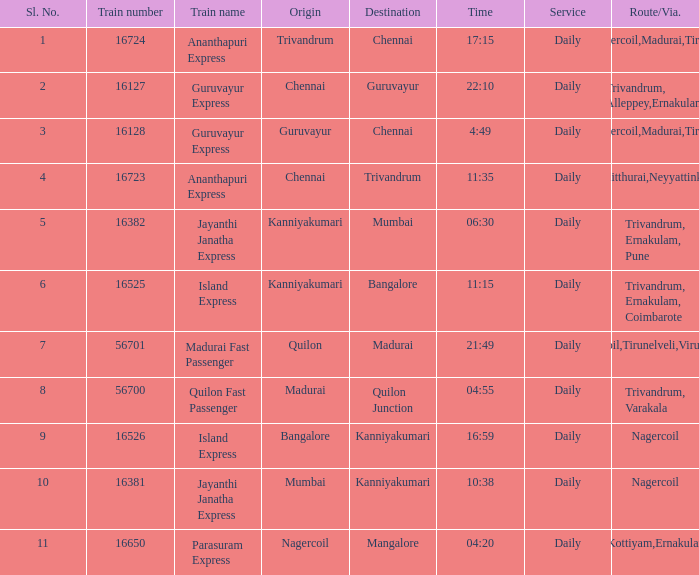What is the destination when the train number is 16526? Kanniyakumari. 